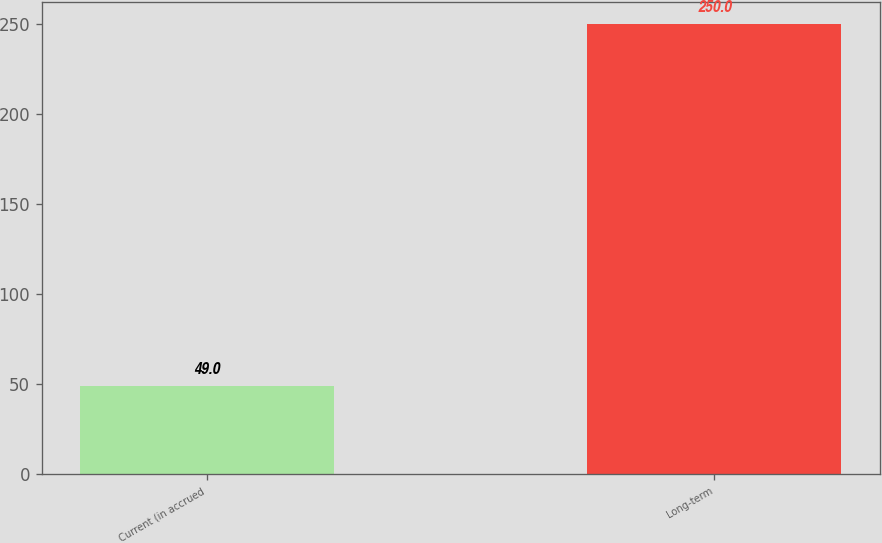Convert chart to OTSL. <chart><loc_0><loc_0><loc_500><loc_500><bar_chart><fcel>Current (in accrued<fcel>Long-term<nl><fcel>49<fcel>250<nl></chart> 